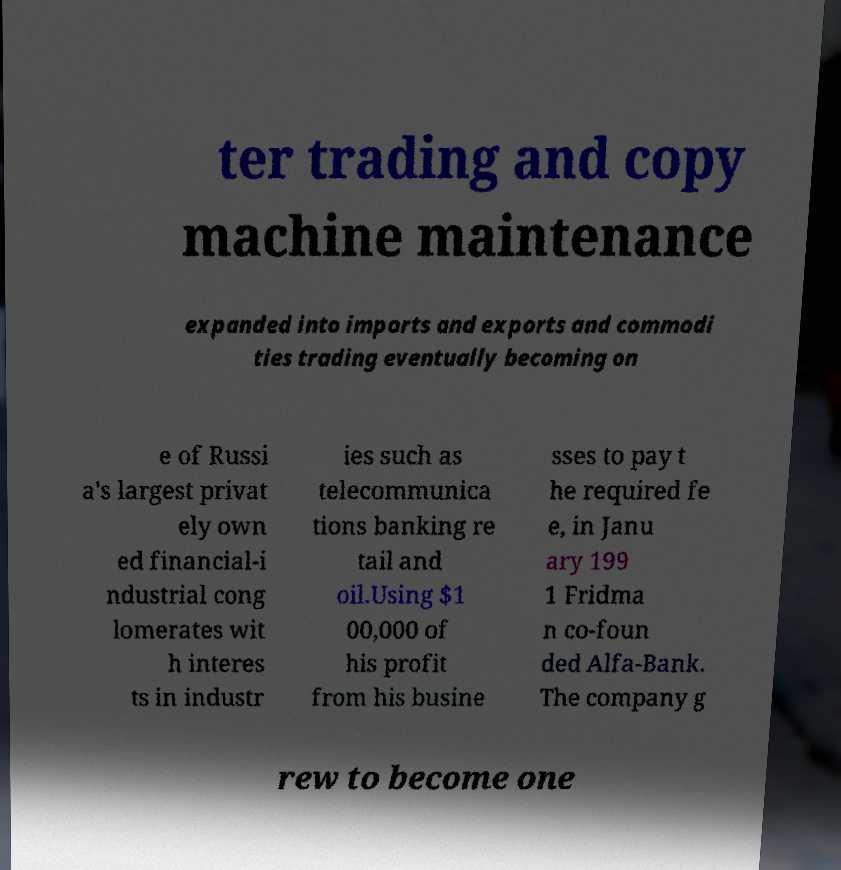Could you extract and type out the text from this image? ter trading and copy machine maintenance expanded into imports and exports and commodi ties trading eventually becoming on e of Russi a's largest privat ely own ed financial-i ndustrial cong lomerates wit h interes ts in industr ies such as telecommunica tions banking re tail and oil.Using $1 00,000 of his profit from his busine sses to pay t he required fe e, in Janu ary 199 1 Fridma n co-foun ded Alfa-Bank. The company g rew to become one 